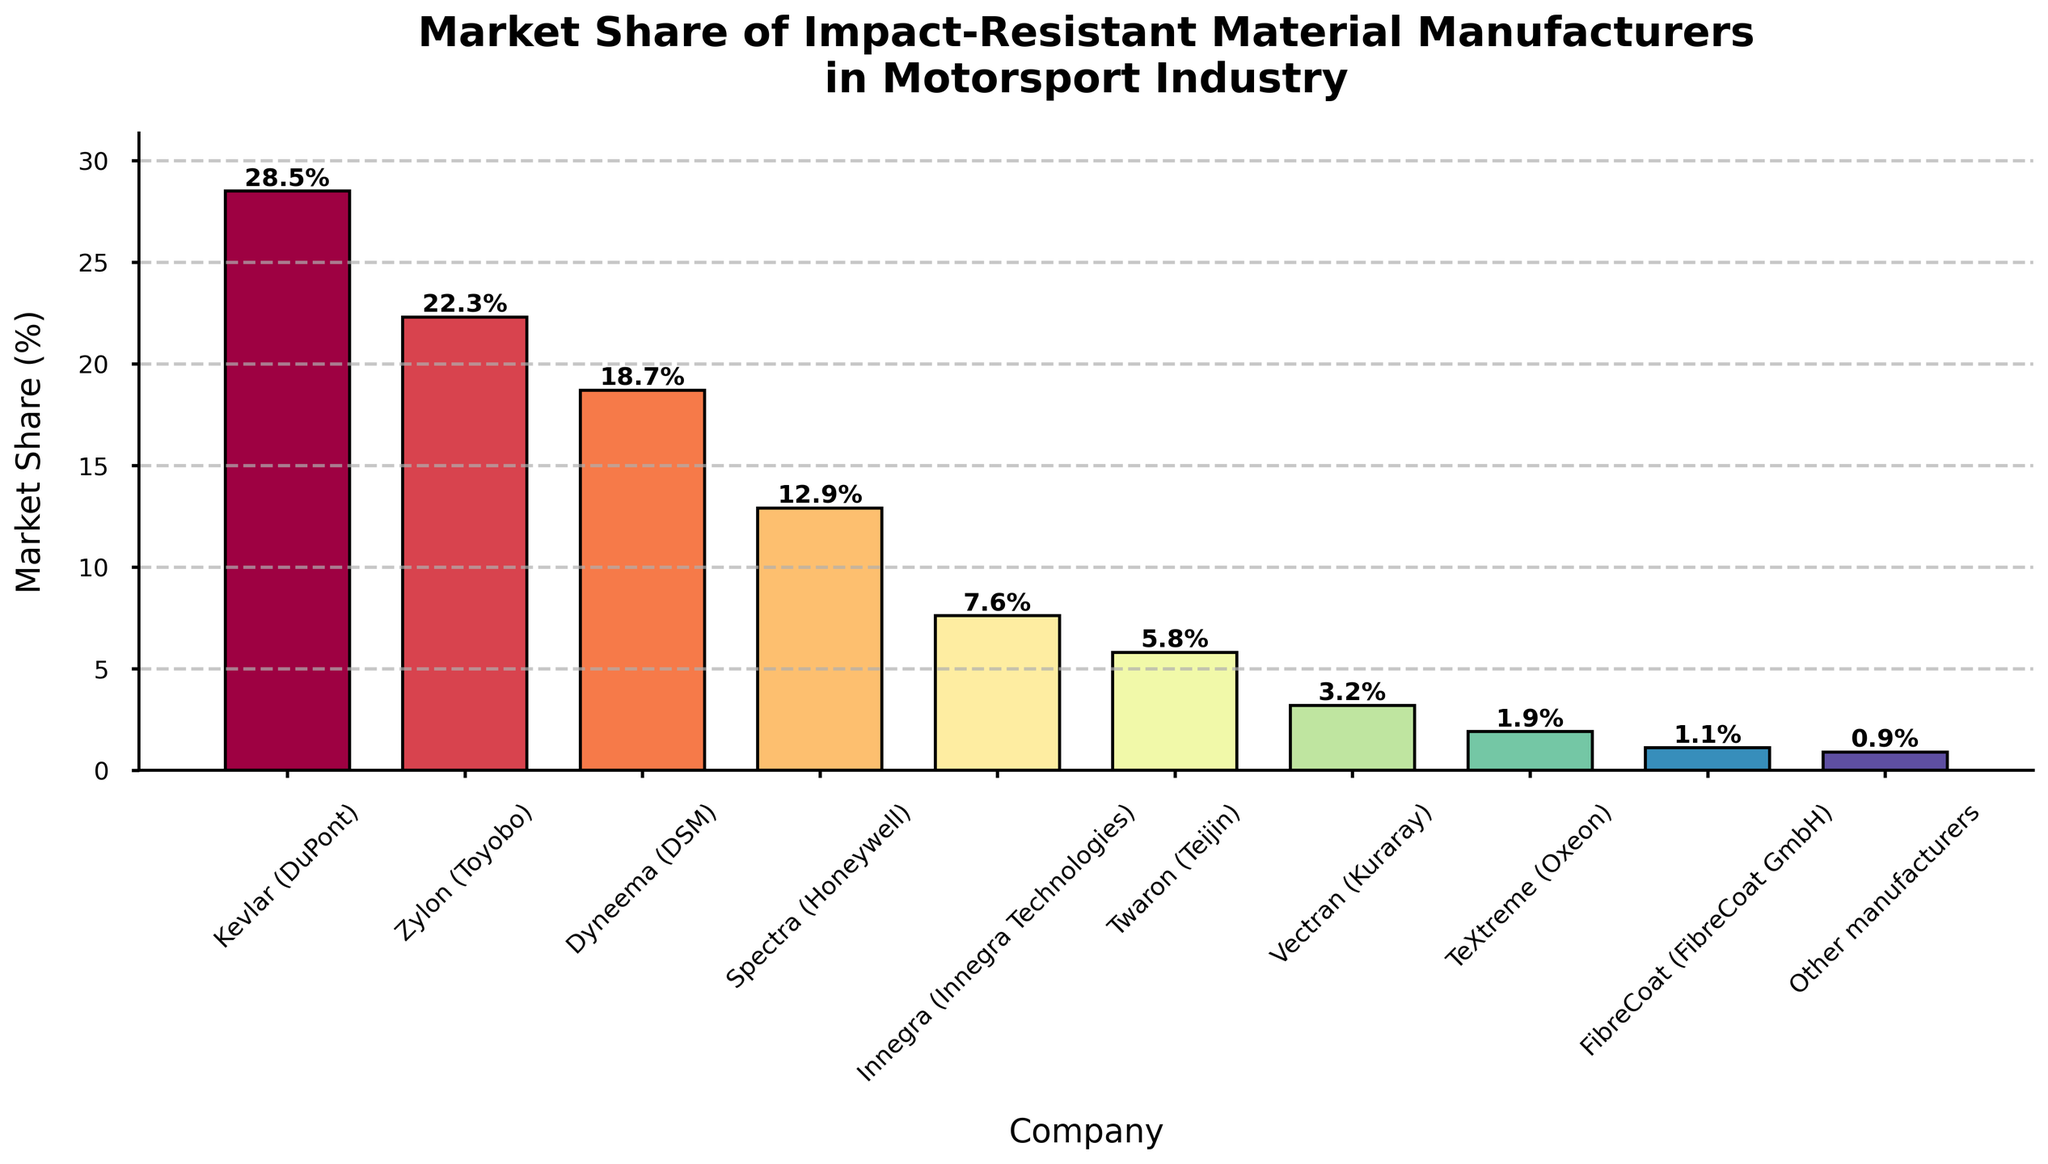Which manufacturer has the largest market share? Look at the highest bar in the figure. Kevlar (DuPont) has the largest market share, represented by the tallest bar
Answer: Kevlar (DuPont) What is the combined market share of Dyneema (DSM) and Spectra (Honeywell)? The market share of Dyneema (DSM) is 18.7% and Spectra (Honeywell) is 12.9%. Sum these values: 18.7 + 12.9 = 31.6
Answer: 31.6% How much more market share does Kevlar (DuPont) have compared to Zylon (Toyobo)? Kevlar (DuPont) has 28.5% market share and Zylon (Toyobo) has 22.3%. The difference is 28.5 - 22.3 = 6.2
Answer: 6.2% Which company has a market share less than 5% but more than 1%? Identify the bars between these values. Twaron (Teijin) at 5.8%, Vectran (Kuraray) at 3.2%, TeXtreme (Oxeon) at 1.9%. Only TeXtreme (Oxeon) and Vectran (Kuraray) fit this criterion
Answer: Vectran (Kuraray) and TeXtreme (Oxeon) What's the average market share of the manufacturers listed? Sum all the listed market shares: 28.5 + 22.3 + 18.7 + 12.9 + 7.6 + 5.8 + 3.2 + 1.9 + 1.1 + 0.9 = 102.9. There are 10 manufacturers, so the average is 102.9 / 10 = 10.29
Answer: 10.29% Which companies have market shares within the range of 20% to 30%? Check the bars that fall between these percentages. Kevlar (DuPont) at 28.5% and Zylon (Toyobo) at 22.3%
Answer: Kevlar (DuPont) and Zylon (Toyobo) Which manufacturer has the smallest market share? Find the shortest bar in the figure, which represents FibreCoat (FibreCoat GmbH)
Answer: FibreCoat (FibreCoat GmbH) Is the market share of Innegra (Innegra Technologies) closer to that of Dyneema (DSM) or Spectra (Honeywell)? Dyneema has 18.7%, Spectra has 12.9%, and Innegra is at 7.6%. The difference between Innegra and Dyneema is 18.7 - 7.6 = 11.1. The difference between Innegra and Spectra is 12.9 - 7.6 = 5.3. Since 5.3 < 11.1, Innegra is closer to Spectra
Answer: Spectra (Honeywell) How does the market share of Twaron (Teijin) compare to the market share of Innegra (Innegra Technologies)? Twaron (Teijin) has a market share of 5.8%, and Innegra (Innegra Technologies) has 7.6%. Twaron has less market share compared to Innegra
Answer: Twaron (Teijin) has less If you combine the market shares of the three smallest manufacturers, what is their total market share? The three smallest manufacturers are TeXtreme (Oxeon) at 1.9%, FibreCoat (FibreCoat GmbH) at 1.1%, and Other manufacturers at 0.9%. Sum these values: 1.9 + 1.1 + 0.9 = 3.9
Answer: 3.9% 